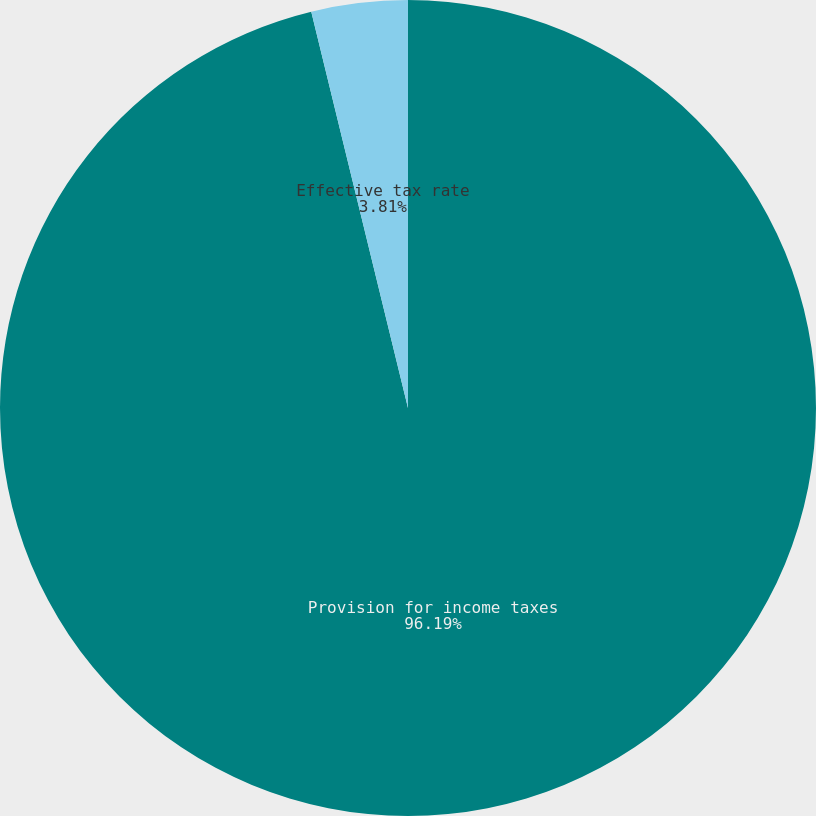Convert chart. <chart><loc_0><loc_0><loc_500><loc_500><pie_chart><fcel>Provision for income taxes<fcel>Effective tax rate<nl><fcel>96.19%<fcel>3.81%<nl></chart> 